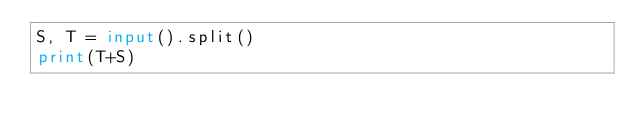<code> <loc_0><loc_0><loc_500><loc_500><_Python_>S, T = input().split()
print(T+S)</code> 